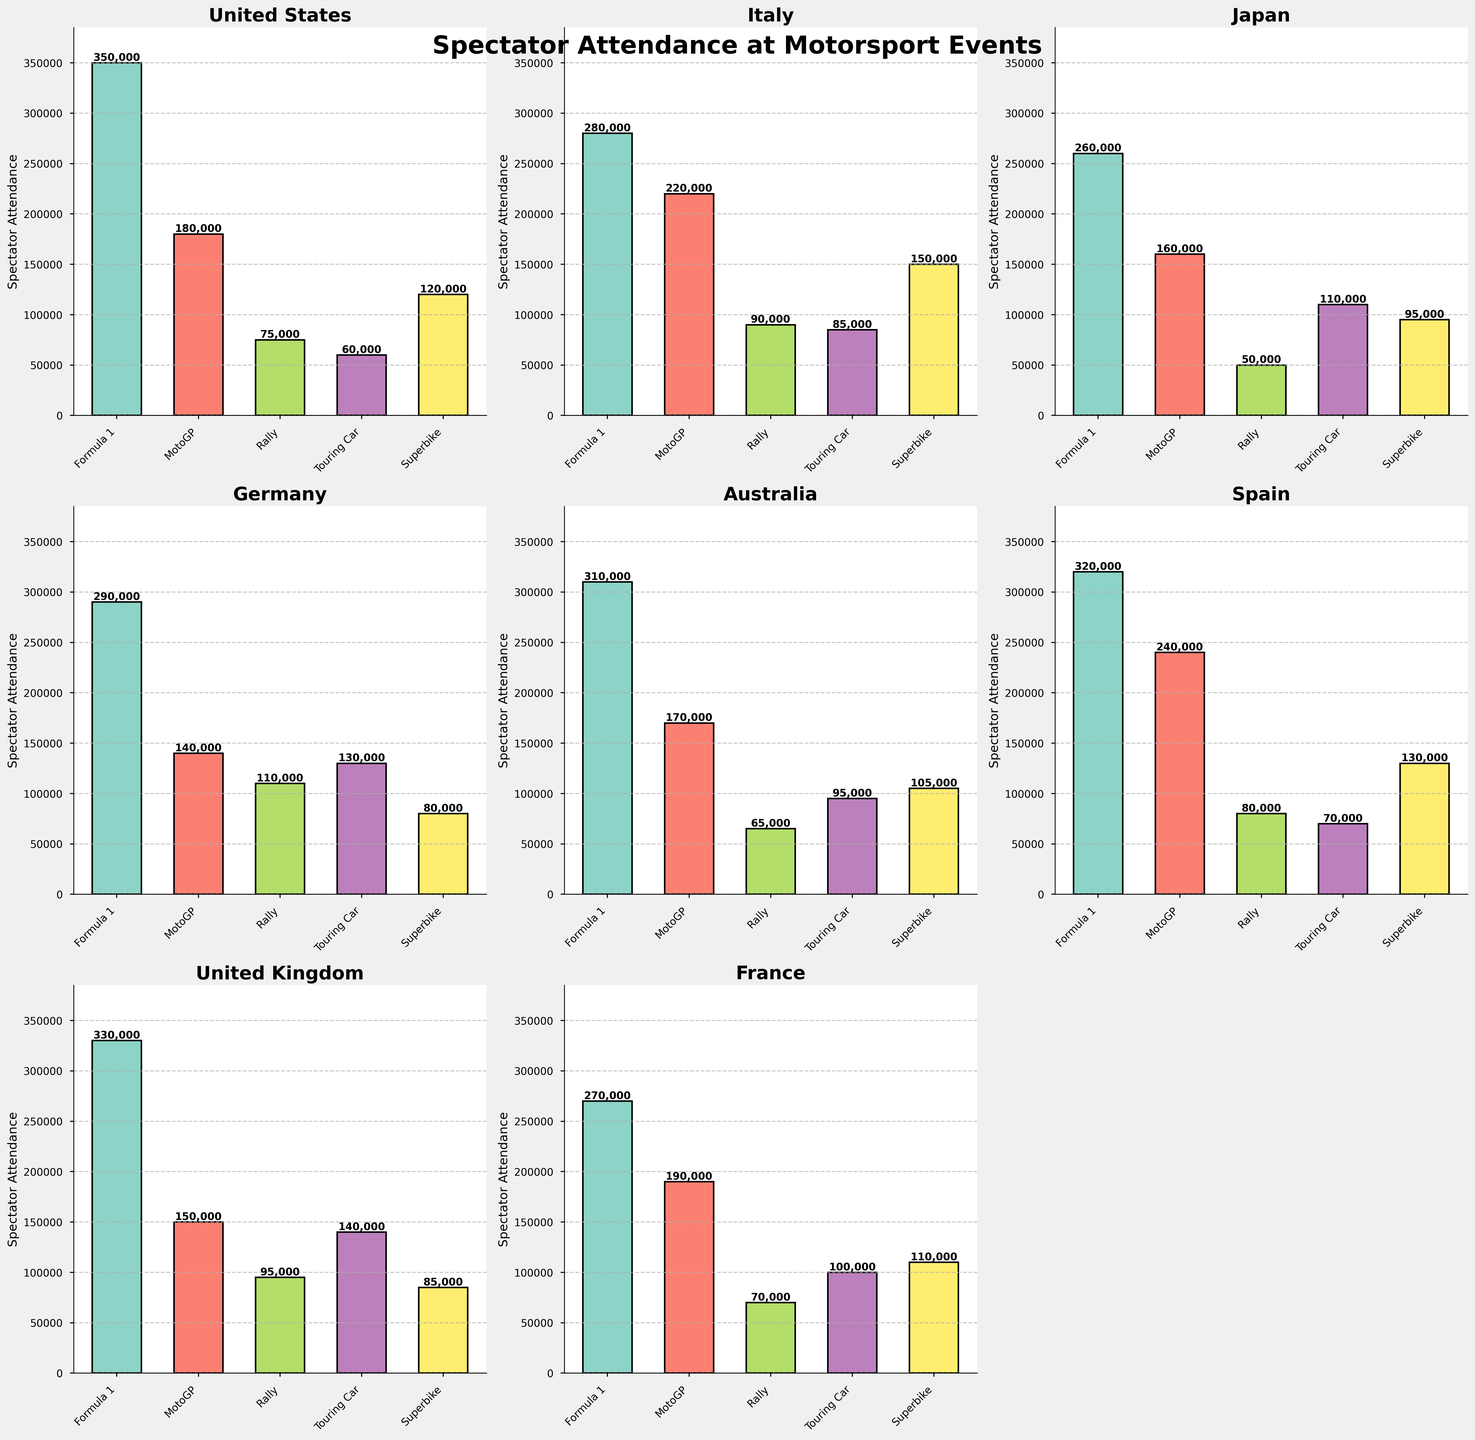Which country has the highest attendance for Formula 1? From the subplot for each country, Identify the bar representing Formula 1 and look for the tallest bar. The tallest Formula 1 bar belongs to the United States.
Answer: United States Which country has the lowest attendance for Superbike events? From the subplot for each country, identify the bar representing Superbike and look for the shortest bar. The shortest Superbike bar belongs to Germany.
Answer: Germany How much more is Italy's MotoGP attendance compared to Japan's MotoGP attendance? Locate the MotoGP bars for Italy and Japan. Italy's MotoGP attendance is 220,000, and Japan's is 160,000. The difference is 220,000 - 160,000 = 60,000.
Answer: 60,000 What is the average spectator attendance for Rally events across all countries? Sum the Rally event attendance across all countries and divide by the number of countries. The sum is 75000 + 90000 + 50000 + 110000 + 65000 + 80000 + 95000 + 70000 = 645,000. There are 8 countries, so the average is 645,000 / 8 = 80,625.
Answer: 80,625 Which country has the highest total spectator attendance across all event types? Sum the attendance for all event types within each country and compare the totals. The United States has the highest total: 350000 + 180000 + 75000 + 60000 + 120000 = 785,000.
Answer: United States How does the spectator attendance for Touring Car events in Germany compare with that in the United Kingdom? Observe the Touring Car bars for Germany and the United Kingdom. Germany’s attendance is 130,000, and the United Kingdom’s is 140,000. Therefore, the United Kingdom has 10,000 more spectators.
Answer: 10,000 more in the United Kingdom What’s the total spectator attendance for all event types in Japan? Sum all event type attendances for Japan: 260000 + 160000 + 50000 + 110000 + 95000 = 675,000.
Answer: 675,000 Which event type has the lowest spectator attendance in Australia? Look at each bar for Australia and identify the shortest one; the shortest bar represents Rally with 65,000 spectators.
Answer: Rally Which event type records the highest overall attendance across all countries? Sum the attendance numbers for each event type across all countries and compare the results. Formula 1 has the highest overall sum: 350000 + 280000 + 260000 + 290000 + 310000 + 320000 + 330000 + 270000 = 2,410,000.
Answer: Formula 1 How many countries have higher attendance for Superbike compared to Rally events? Compare the heights of the Superbike and Rally bars within each subplot. Italy, Japan, and France have higher Superbike attendance than Rally attendance, so the count is 3.
Answer: 3 